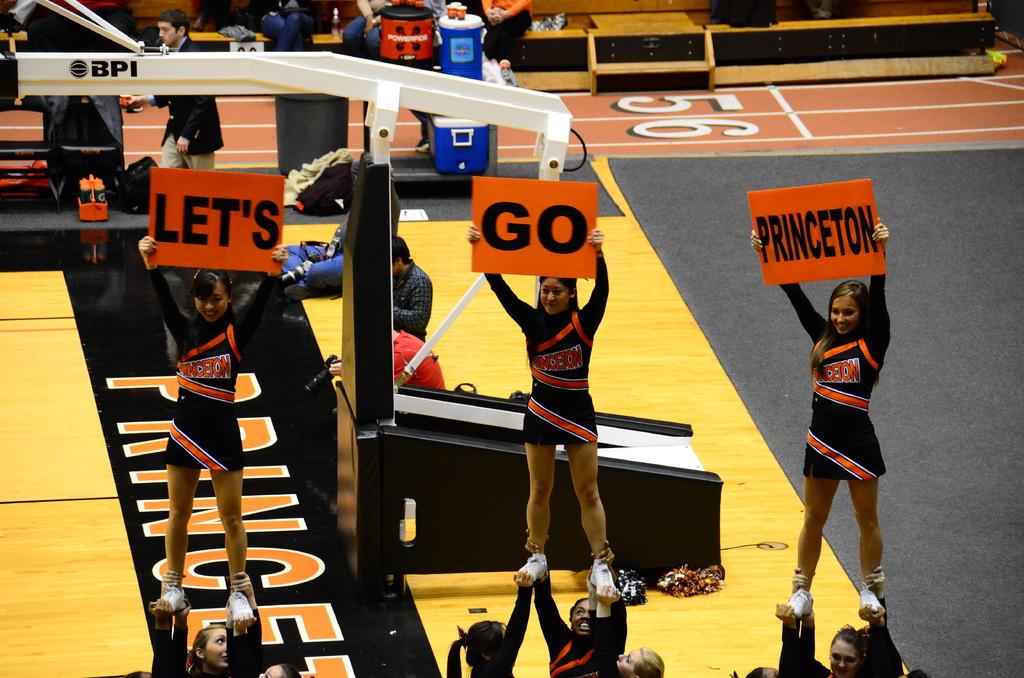<image>
Present a compact description of the photo's key features. Cheerleaders holding a three piece Let's go Princeton sign 